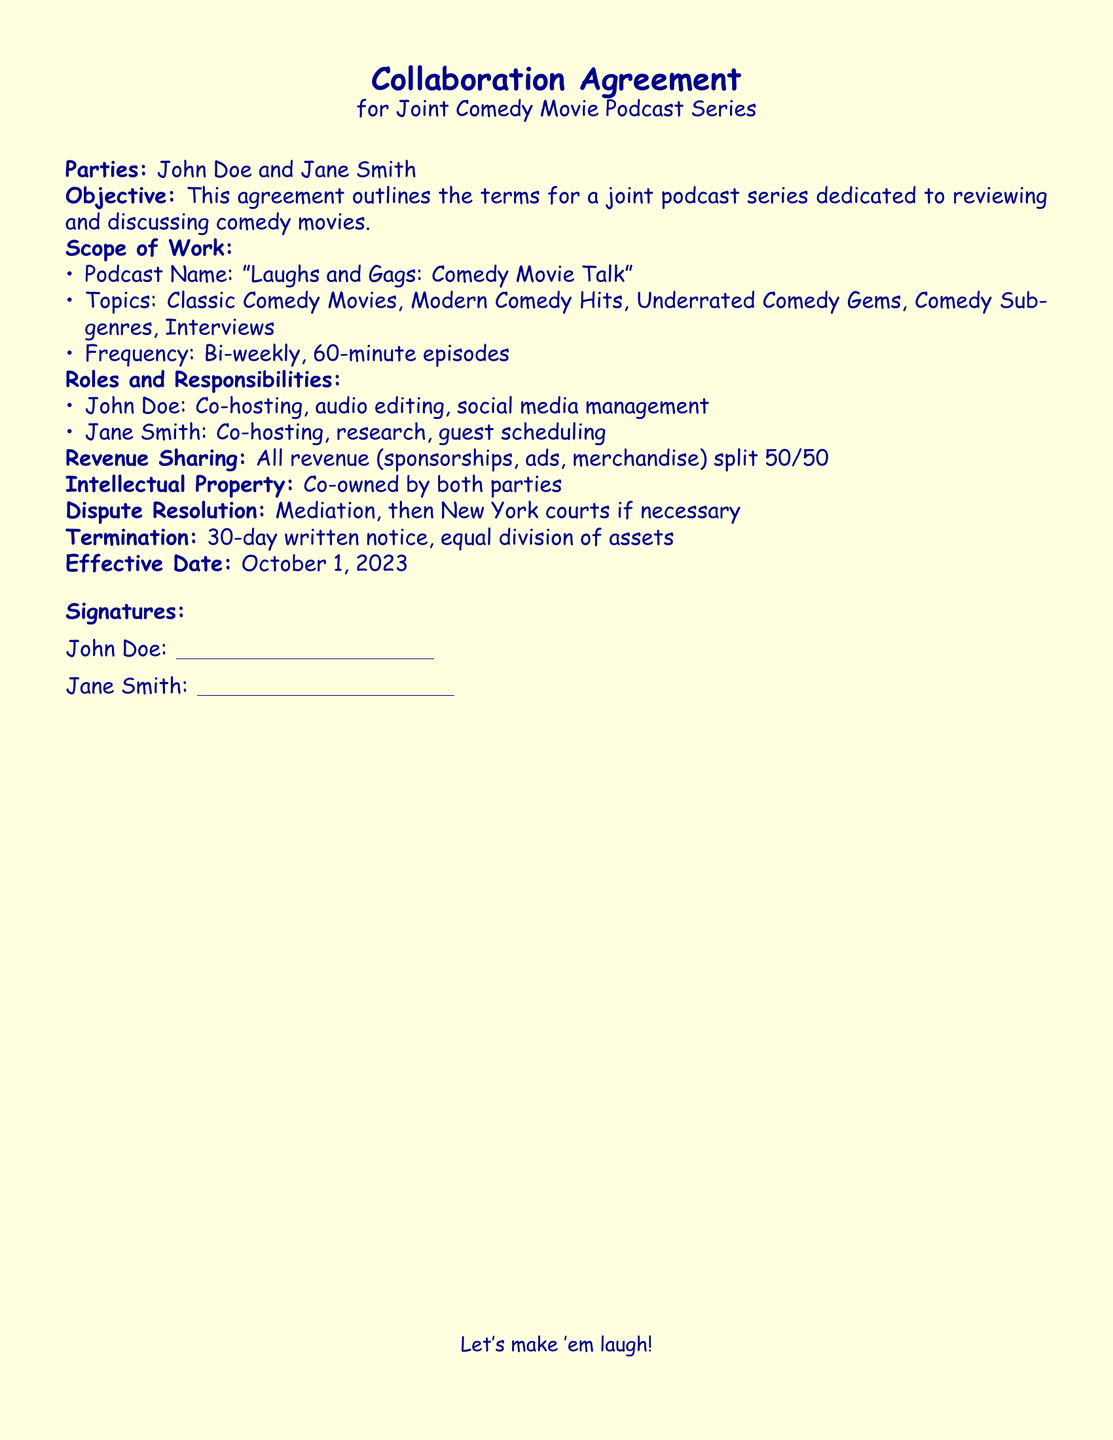What is the podcast name? The podcast name is explicitly mentioned as "Laughs and Gags: Comedy Movie Talk."
Answer: Laughs and Gags: Comedy Movie Talk What are the names of the parties involved? The parties involved are John Doe and Jane Smith as stated in the document.
Answer: John Doe and Jane Smith What is the frequency of the podcast episodes? The frequency is detailed under the scope of work, stating that episodes will be released bi-weekly.
Answer: Bi-weekly How long will each episode be? The length of each episode is specified as 60 minutes in the scope of work.
Answer: 60 minutes Which responsibilities does John Doe have? John Doe's responsibilities include co-hosting, audio editing, and social media management as outlined in the roles and responsibilities section.
Answer: Co-hosting, audio editing, social media management What type of revenue sharing is mentioned? The revenue sharing details a 50/50 split, indicating how the revenue will be divided.
Answer: 50/50 When does the agreement become effective? The effective date is clearly stated as October 1, 2023.
Answer: October 1, 2023 What is the process for dispute resolution? The document specifies mediation followed by New York courts as the process for handling disputes.
Answer: Mediation, then New York courts 